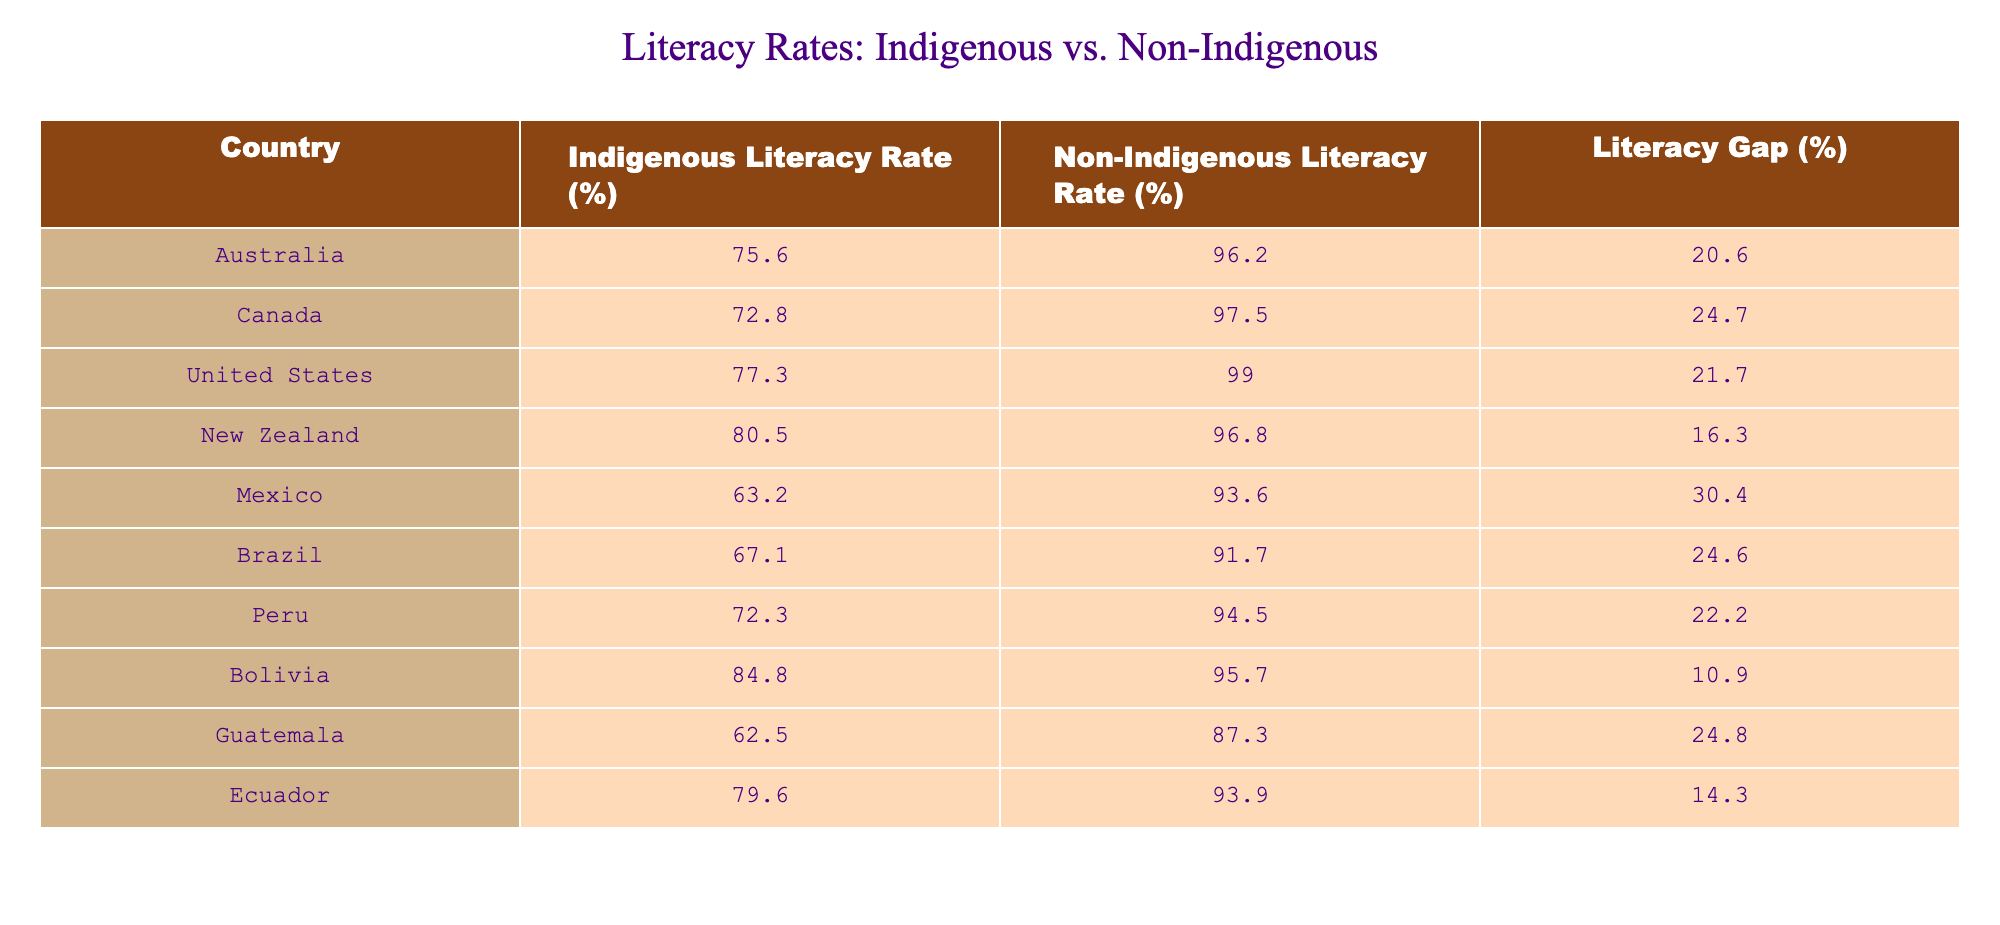What is the highest indigenous literacy rate among the listed countries? The highest indigenous literacy rate in the table is 84.8% for Bolivia. This is determined by comparing the Indigenous Literacy Rate (%) column across all countries.
Answer: 84.8% Which country has the largest literacy gap between indigenous and non-indigenous populations? The country with the largest literacy gap is Mexico, with a gap of 30.4%. This is found by looking at the Literacy Gap (%) column and identifying the highest value.
Answer: 30.4% What is the average literacy rate for non-indigenous populations across the listed countries? To find the average, we sum the Non-Indigenous Literacy Rates: (96.2 + 97.5 + 99.0 + 96.8 + 93.6 + 91.7 + 94.5 + 95.7 + 87.3 + 93.9) =  95.42, and divide by the number of countries (10) to get the average of 95.42%.
Answer: 95.42% Is the indigenous literacy rate in New Zealand higher than the average indigenous literacy rate of the listed countries? Firstly, we calculate the average indigenous literacy rate by summing up all the Indigenous Literacy Rates: (75.6 + 72.8 + 77.3 + 80.5 + 63.2 + 67.1 + 72.3 + 84.8 + 62.5 + 79.6) =  72.88% and dividing by 10 gives us 72.88%. Since New Zealand's rate is 80.5%, it is indeed higher than the average.
Answer: Yes How many countries have an indigenous literacy rate below 70%? By examining the Indigenous Literacy Rates, we see that Mexico (63.2%), Guatemala (62.5%), and Brazil (67.1%) are below 70%. This gives us 3 countries in total.
Answer: 3 